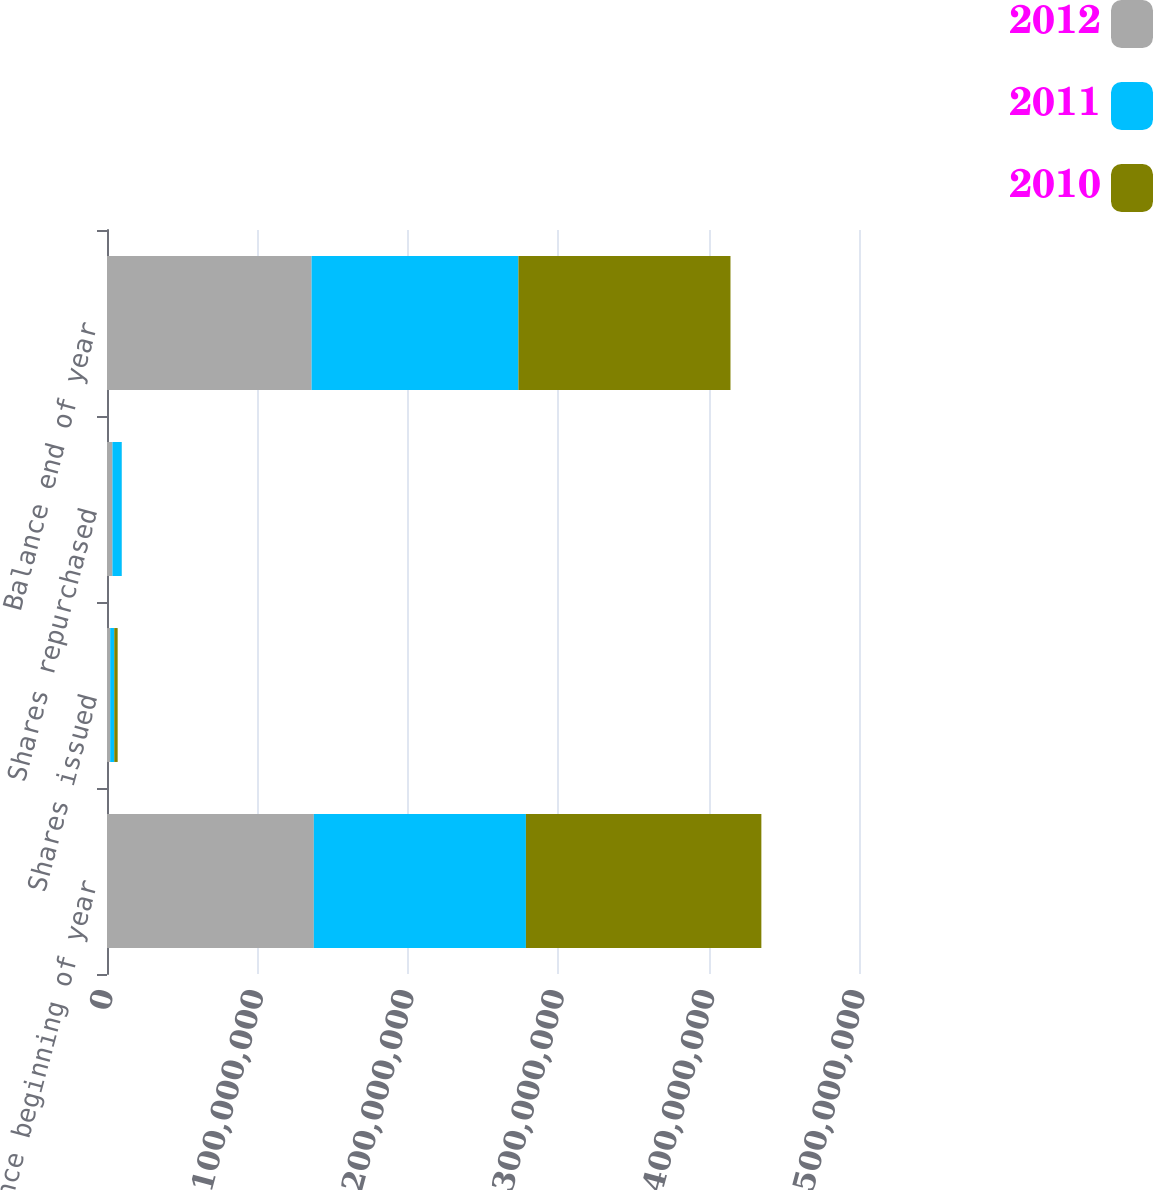Convert chart. <chart><loc_0><loc_0><loc_500><loc_500><stacked_bar_chart><ecel><fcel>Balance beginning of year<fcel>Shares issued<fcel>Shares repurchased<fcel>Balance end of year<nl><fcel>2012<fcel>1.3752e+08<fcel>2.11417e+06<fcel>3.61646e+06<fcel>1.36018e+08<nl><fcel>2011<fcel>1.4101e+08<fcel>2.7023e+06<fcel>6.19212e+06<fcel>1.3752e+08<nl><fcel>2010<fcel>1.56552e+08<fcel>2.27244e+06<fcel>17815<fcel>1.4101e+08<nl></chart> 